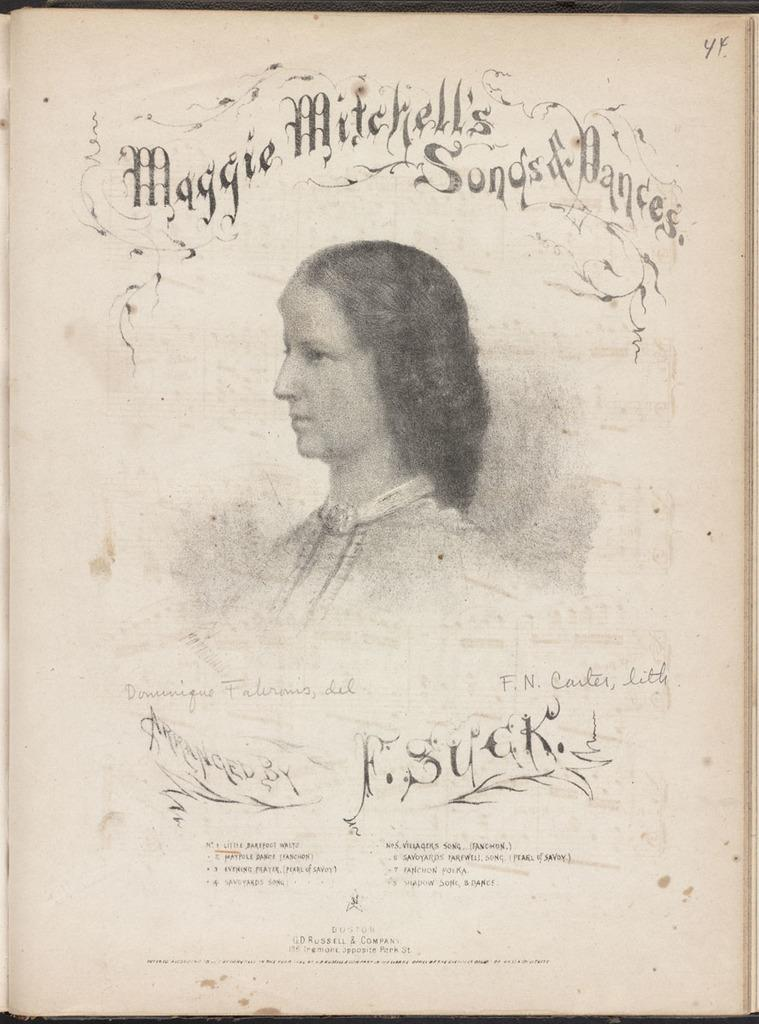What is featured on the poster in the image? There is a poster in the image that contains a picture of a woman. In which direction is the woman looking in the poster? The woman is looking to the left side in the poster. Where is the text located on the poster? There is text on the top and bottom sides of the picture. What type of sticks are being used by the woman in the image? There are no sticks present in the image; it features a poster with a picture of a woman. Is there a birthday celebration happening in the image? There is no indication of a birthday celebration in the image; it only shows a poster with a picture of a woman. 